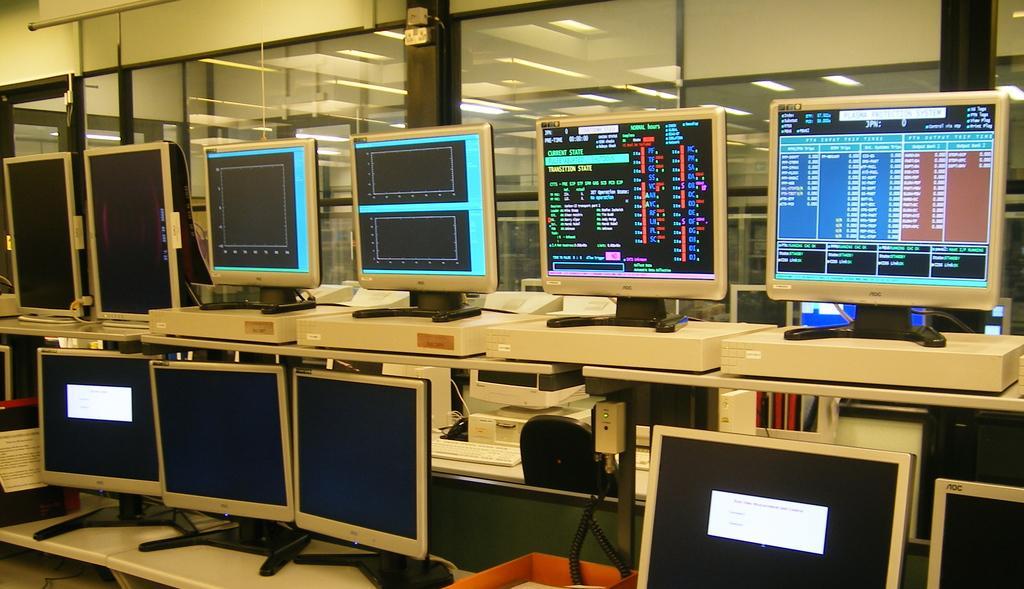Could you give a brief overview of what you see in this image? This image consists of many computers kept on a desk. In the background, there is a wall along with glass windows. 